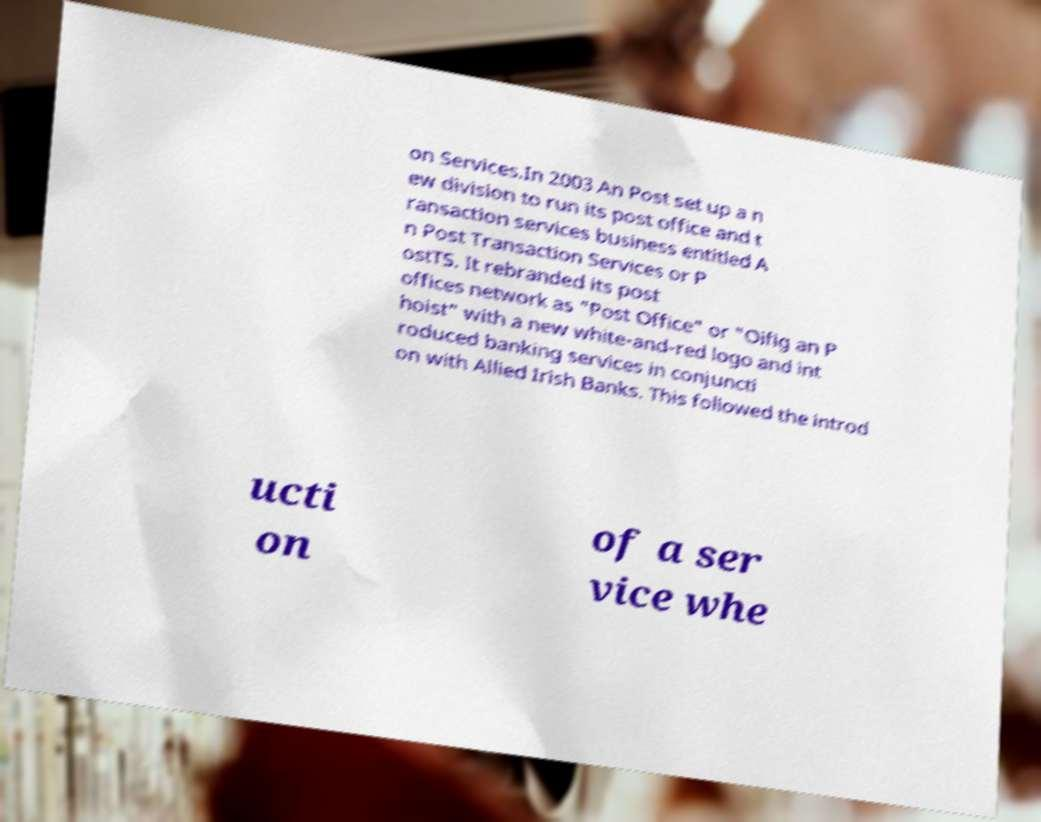Could you extract and type out the text from this image? on Services.In 2003 An Post set up a n ew division to run its post office and t ransaction services business entitled A n Post Transaction Services or P ostTS. It rebranded its post offices network as "Post Office" or "Oifig an P hoist" with a new white-and-red logo and int roduced banking services in conjuncti on with Allied Irish Banks. This followed the introd ucti on of a ser vice whe 